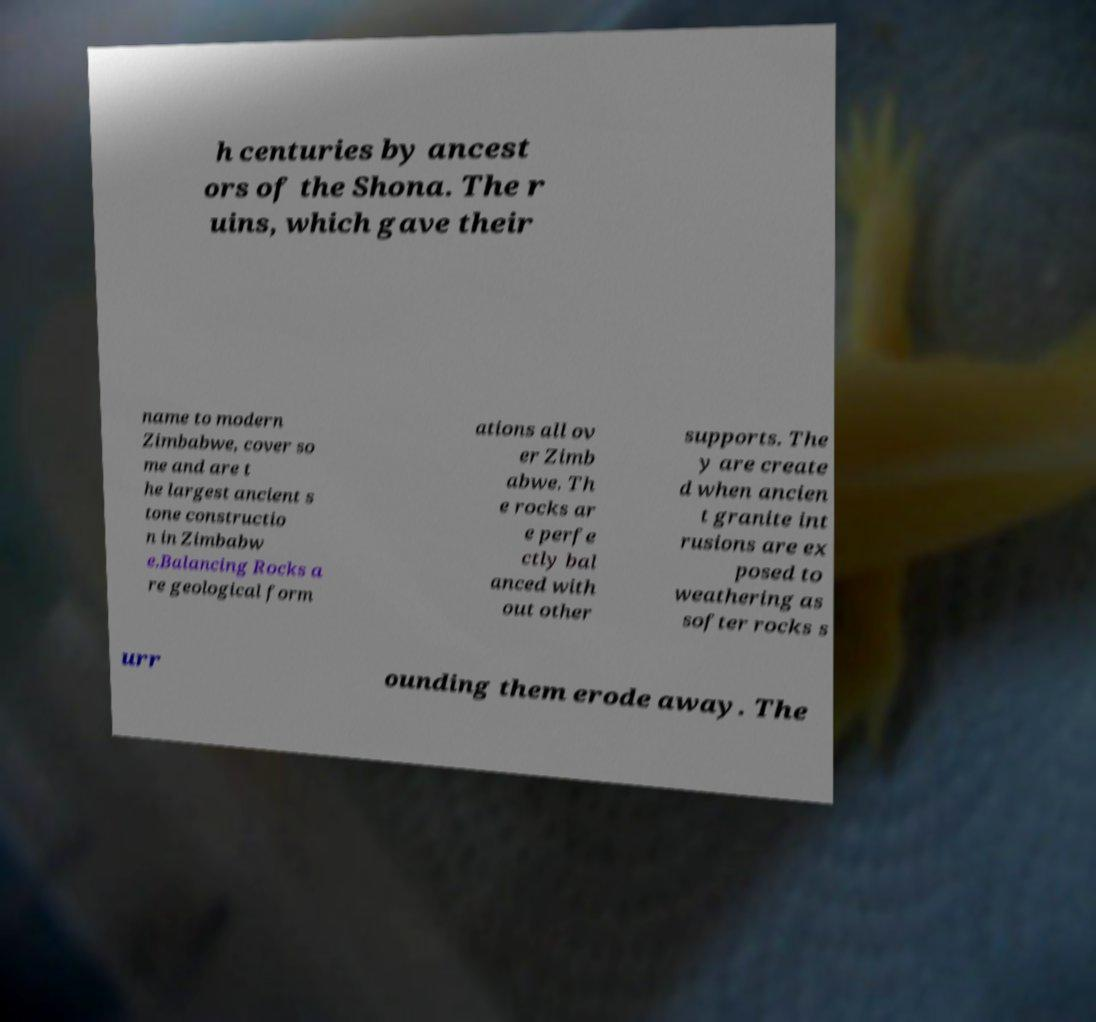Can you accurately transcribe the text from the provided image for me? h centuries by ancest ors of the Shona. The r uins, which gave their name to modern Zimbabwe, cover so me and are t he largest ancient s tone constructio n in Zimbabw e.Balancing Rocks a re geological form ations all ov er Zimb abwe. Th e rocks ar e perfe ctly bal anced with out other supports. The y are create d when ancien t granite int rusions are ex posed to weathering as softer rocks s urr ounding them erode away. The 